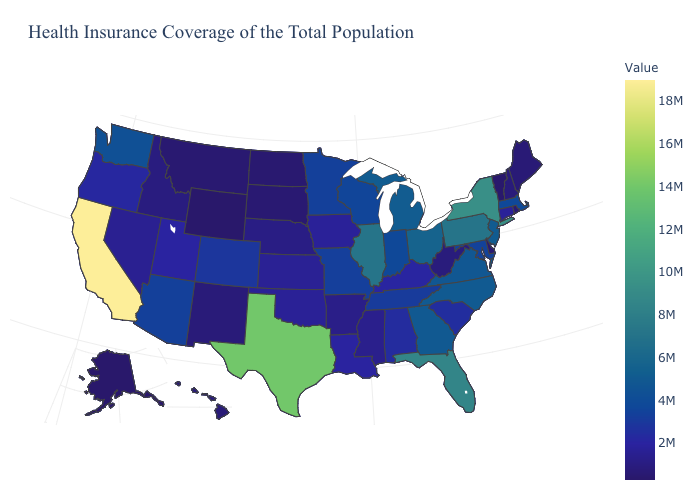Among the states that border Colorado , which have the lowest value?
Keep it brief. Wyoming. Does Georgia have a lower value than Alabama?
Be succinct. No. Does New Jersey have the lowest value in the Northeast?
Write a very short answer. No. Is the legend a continuous bar?
Concise answer only. Yes. Which states have the lowest value in the USA?
Give a very brief answer. Wyoming. Does Missouri have the lowest value in the MidWest?
Concise answer only. No. Does California have the highest value in the USA?
Quick response, please. Yes. 